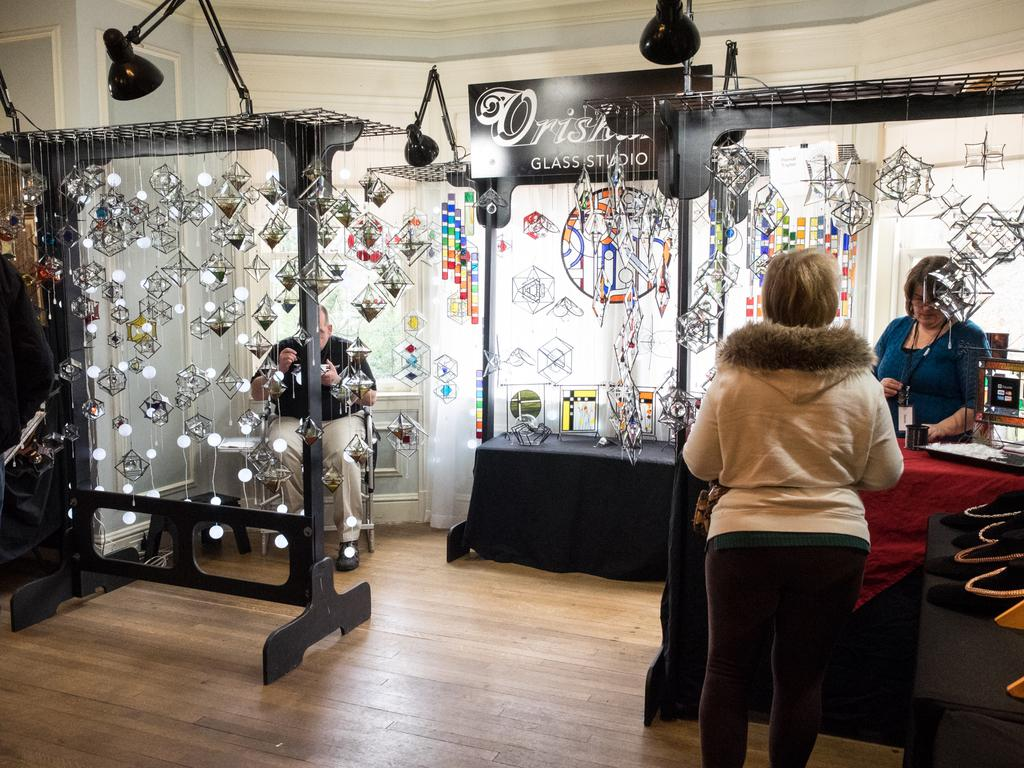How many women are in the image? There are two women in the image. What are the women doing in the image? The women are standing near a table. What type of decorations can be seen in the image? There are decorative hangings in the image. What type of lighting is present in the image? There are lamps in the image. What is visible in the background of the image? There is a wall in the background of the image. Is there an earthquake happening in the image? No, there is no indication of an earthquake in the image. Whose birthday is being celebrated in the image? There is no indication of a birthday celebration in the image. 